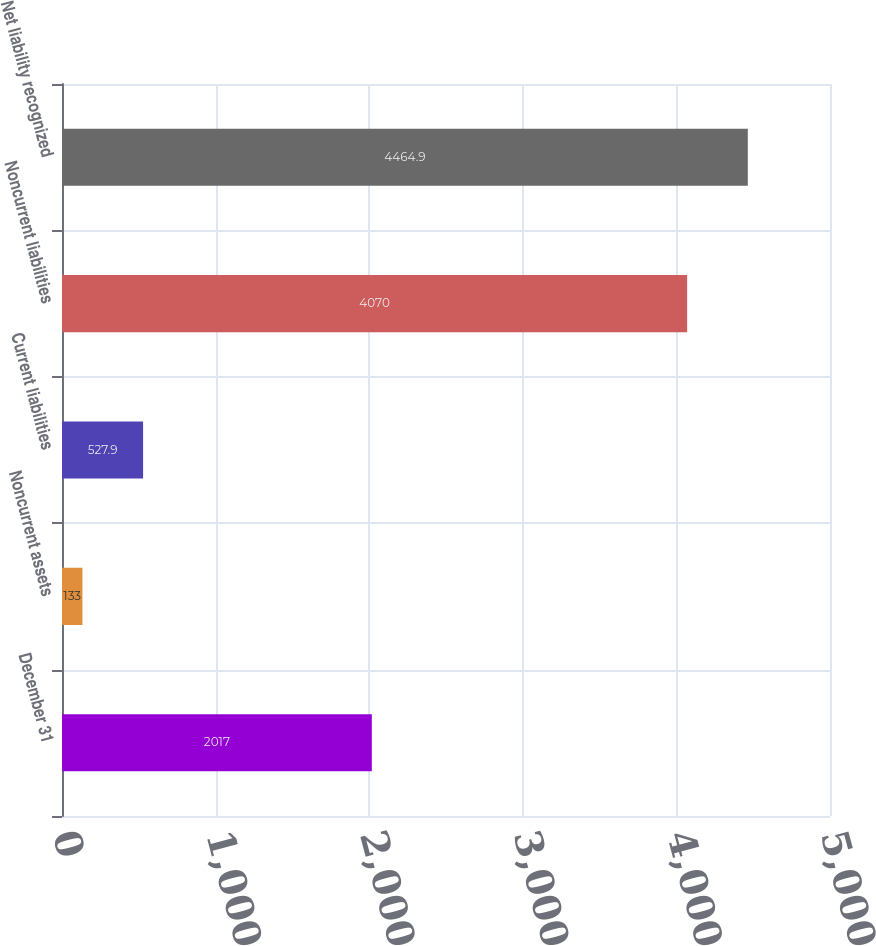Convert chart. <chart><loc_0><loc_0><loc_500><loc_500><bar_chart><fcel>December 31<fcel>Noncurrent assets<fcel>Current liabilities<fcel>Noncurrent liabilities<fcel>Net liability recognized<nl><fcel>2017<fcel>133<fcel>527.9<fcel>4070<fcel>4464.9<nl></chart> 